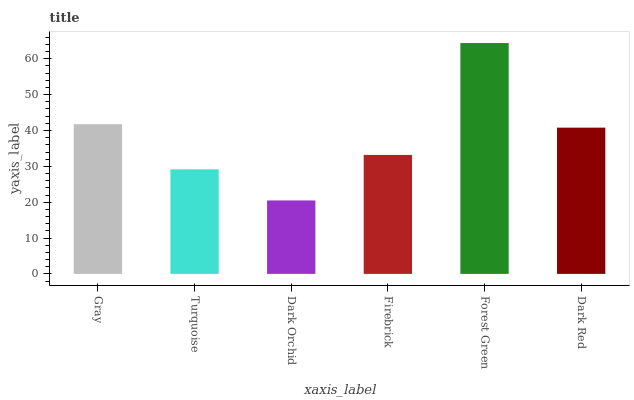Is Dark Orchid the minimum?
Answer yes or no. Yes. Is Forest Green the maximum?
Answer yes or no. Yes. Is Turquoise the minimum?
Answer yes or no. No. Is Turquoise the maximum?
Answer yes or no. No. Is Gray greater than Turquoise?
Answer yes or no. Yes. Is Turquoise less than Gray?
Answer yes or no. Yes. Is Turquoise greater than Gray?
Answer yes or no. No. Is Gray less than Turquoise?
Answer yes or no. No. Is Dark Red the high median?
Answer yes or no. Yes. Is Firebrick the low median?
Answer yes or no. Yes. Is Forest Green the high median?
Answer yes or no. No. Is Dark Red the low median?
Answer yes or no. No. 